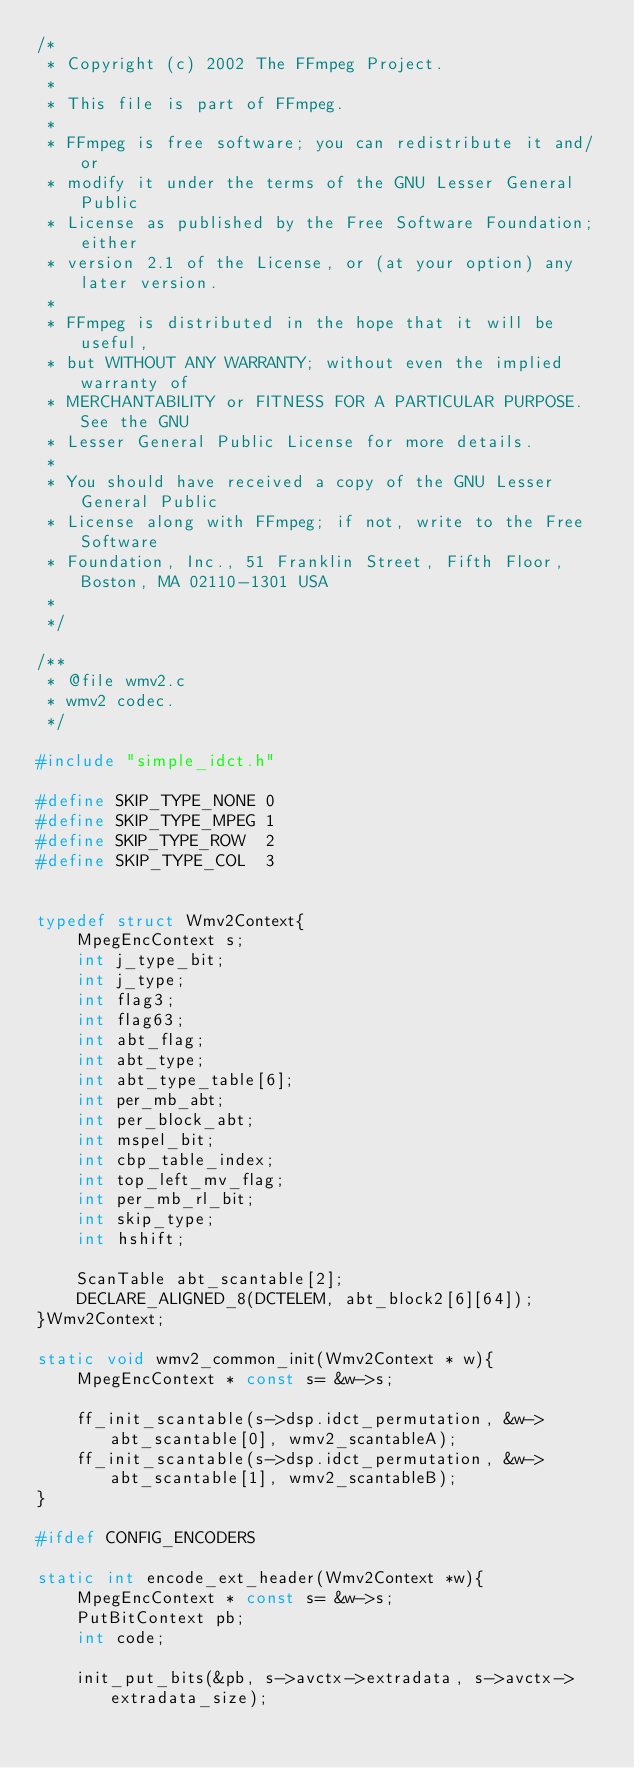<code> <loc_0><loc_0><loc_500><loc_500><_C_>/*
 * Copyright (c) 2002 The FFmpeg Project.
 *
 * This file is part of FFmpeg.
 *
 * FFmpeg is free software; you can redistribute it and/or
 * modify it under the terms of the GNU Lesser General Public
 * License as published by the Free Software Foundation; either
 * version 2.1 of the License, or (at your option) any later version.
 *
 * FFmpeg is distributed in the hope that it will be useful,
 * but WITHOUT ANY WARRANTY; without even the implied warranty of
 * MERCHANTABILITY or FITNESS FOR A PARTICULAR PURPOSE.  See the GNU
 * Lesser General Public License for more details.
 *
 * You should have received a copy of the GNU Lesser General Public
 * License along with FFmpeg; if not, write to the Free Software
 * Foundation, Inc., 51 Franklin Street, Fifth Floor, Boston, MA 02110-1301 USA
 *
 */

/**
 * @file wmv2.c
 * wmv2 codec.
 */

#include "simple_idct.h"

#define SKIP_TYPE_NONE 0
#define SKIP_TYPE_MPEG 1
#define SKIP_TYPE_ROW  2
#define SKIP_TYPE_COL  3


typedef struct Wmv2Context{
    MpegEncContext s;
    int j_type_bit;
    int j_type;
    int flag3;
    int flag63;
    int abt_flag;
    int abt_type;
    int abt_type_table[6];
    int per_mb_abt;
    int per_block_abt;
    int mspel_bit;
    int cbp_table_index;
    int top_left_mv_flag;
    int per_mb_rl_bit;
    int skip_type;
    int hshift;

    ScanTable abt_scantable[2];
    DECLARE_ALIGNED_8(DCTELEM, abt_block2[6][64]);
}Wmv2Context;

static void wmv2_common_init(Wmv2Context * w){
    MpegEncContext * const s= &w->s;

    ff_init_scantable(s->dsp.idct_permutation, &w->abt_scantable[0], wmv2_scantableA);
    ff_init_scantable(s->dsp.idct_permutation, &w->abt_scantable[1], wmv2_scantableB);
}

#ifdef CONFIG_ENCODERS

static int encode_ext_header(Wmv2Context *w){
    MpegEncContext * const s= &w->s;
    PutBitContext pb;
    int code;

    init_put_bits(&pb, s->avctx->extradata, s->avctx->extradata_size);
</code> 